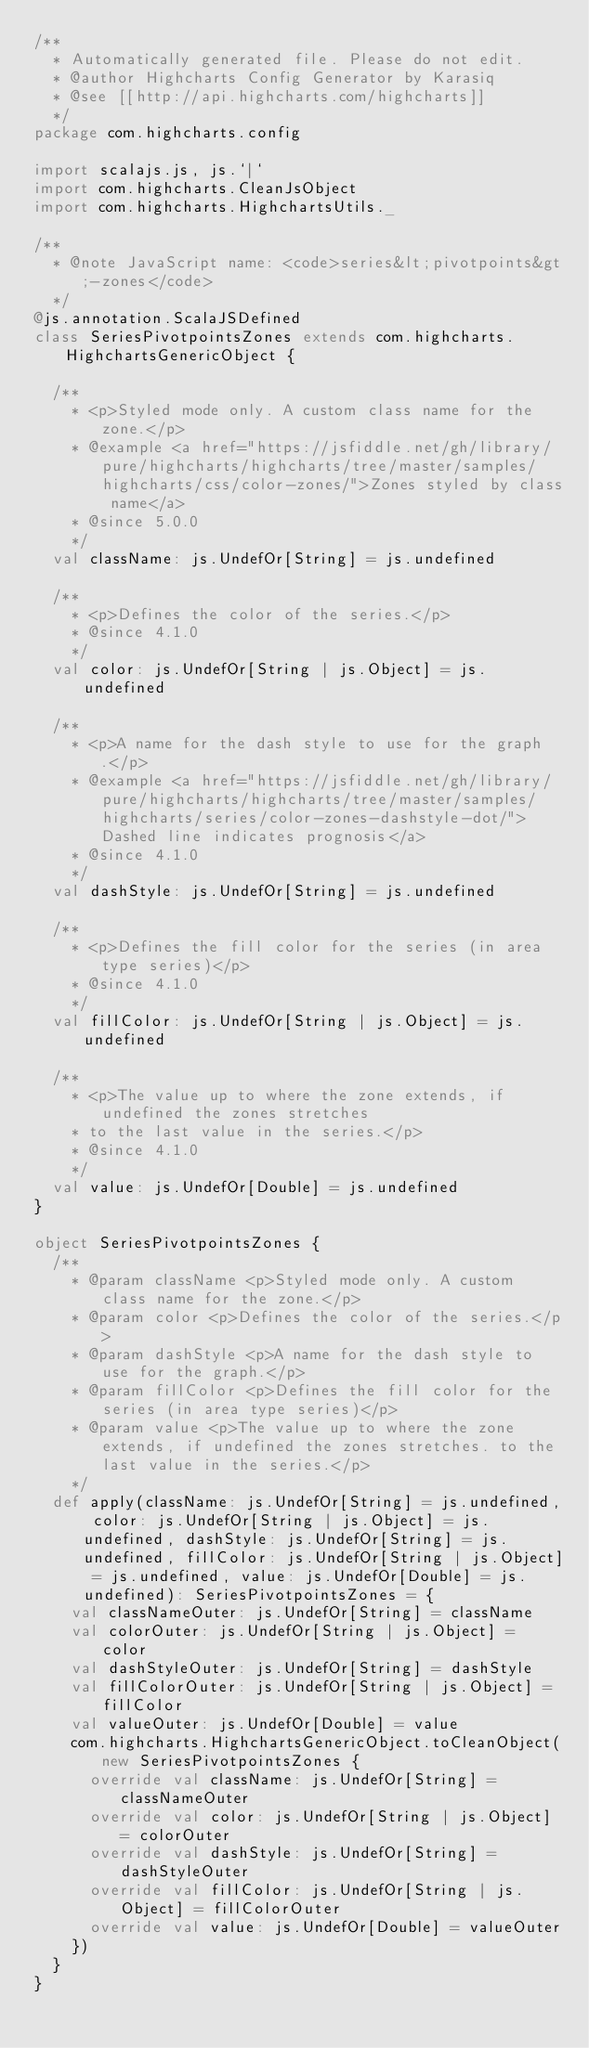Convert code to text. <code><loc_0><loc_0><loc_500><loc_500><_Scala_>/**
  * Automatically generated file. Please do not edit.
  * @author Highcharts Config Generator by Karasiq
  * @see [[http://api.highcharts.com/highcharts]]
  */
package com.highcharts.config

import scalajs.js, js.`|`
import com.highcharts.CleanJsObject
import com.highcharts.HighchartsUtils._

/**
  * @note JavaScript name: <code>series&lt;pivotpoints&gt;-zones</code>
  */
@js.annotation.ScalaJSDefined
class SeriesPivotpointsZones extends com.highcharts.HighchartsGenericObject {

  /**
    * <p>Styled mode only. A custom class name for the zone.</p>
    * @example <a href="https://jsfiddle.net/gh/library/pure/highcharts/highcharts/tree/master/samples/highcharts/css/color-zones/">Zones styled by class name</a>
    * @since 5.0.0
    */
  val className: js.UndefOr[String] = js.undefined

  /**
    * <p>Defines the color of the series.</p>
    * @since 4.1.0
    */
  val color: js.UndefOr[String | js.Object] = js.undefined

  /**
    * <p>A name for the dash style to use for the graph.</p>
    * @example <a href="https://jsfiddle.net/gh/library/pure/highcharts/highcharts/tree/master/samples/highcharts/series/color-zones-dashstyle-dot/">Dashed line indicates prognosis</a>
    * @since 4.1.0
    */
  val dashStyle: js.UndefOr[String] = js.undefined

  /**
    * <p>Defines the fill color for the series (in area type series)</p>
    * @since 4.1.0
    */
  val fillColor: js.UndefOr[String | js.Object] = js.undefined

  /**
    * <p>The value up to where the zone extends, if undefined the zones stretches
    * to the last value in the series.</p>
    * @since 4.1.0
    */
  val value: js.UndefOr[Double] = js.undefined
}

object SeriesPivotpointsZones {
  /**
    * @param className <p>Styled mode only. A custom class name for the zone.</p>
    * @param color <p>Defines the color of the series.</p>
    * @param dashStyle <p>A name for the dash style to use for the graph.</p>
    * @param fillColor <p>Defines the fill color for the series (in area type series)</p>
    * @param value <p>The value up to where the zone extends, if undefined the zones stretches. to the last value in the series.</p>
    */
  def apply(className: js.UndefOr[String] = js.undefined, color: js.UndefOr[String | js.Object] = js.undefined, dashStyle: js.UndefOr[String] = js.undefined, fillColor: js.UndefOr[String | js.Object] = js.undefined, value: js.UndefOr[Double] = js.undefined): SeriesPivotpointsZones = {
    val classNameOuter: js.UndefOr[String] = className
    val colorOuter: js.UndefOr[String | js.Object] = color
    val dashStyleOuter: js.UndefOr[String] = dashStyle
    val fillColorOuter: js.UndefOr[String | js.Object] = fillColor
    val valueOuter: js.UndefOr[Double] = value
    com.highcharts.HighchartsGenericObject.toCleanObject(new SeriesPivotpointsZones {
      override val className: js.UndefOr[String] = classNameOuter
      override val color: js.UndefOr[String | js.Object] = colorOuter
      override val dashStyle: js.UndefOr[String] = dashStyleOuter
      override val fillColor: js.UndefOr[String | js.Object] = fillColorOuter
      override val value: js.UndefOr[Double] = valueOuter
    })
  }
}
</code> 